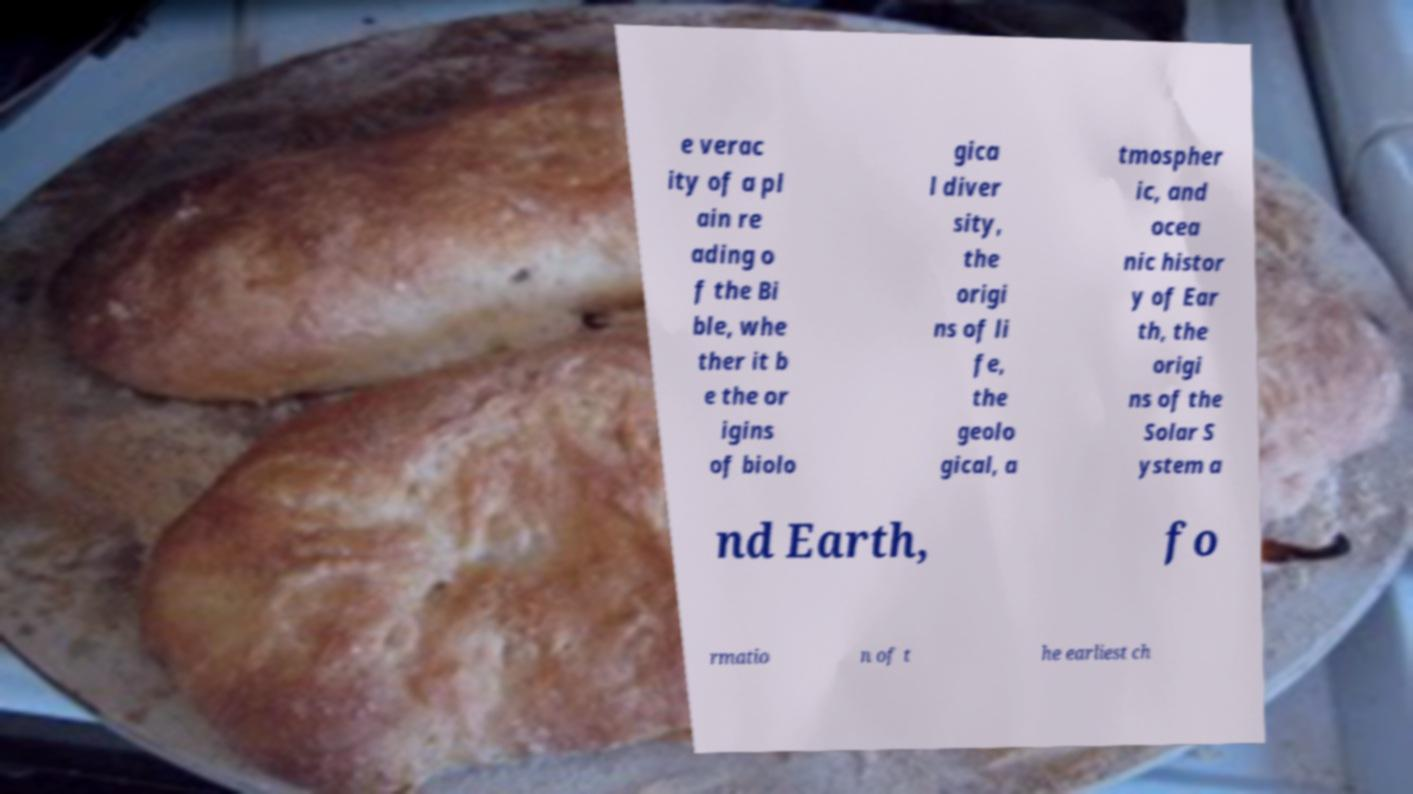Can you read and provide the text displayed in the image?This photo seems to have some interesting text. Can you extract and type it out for me? e verac ity of a pl ain re ading o f the Bi ble, whe ther it b e the or igins of biolo gica l diver sity, the origi ns of li fe, the geolo gical, a tmospher ic, and ocea nic histor y of Ear th, the origi ns of the Solar S ystem a nd Earth, fo rmatio n of t he earliest ch 